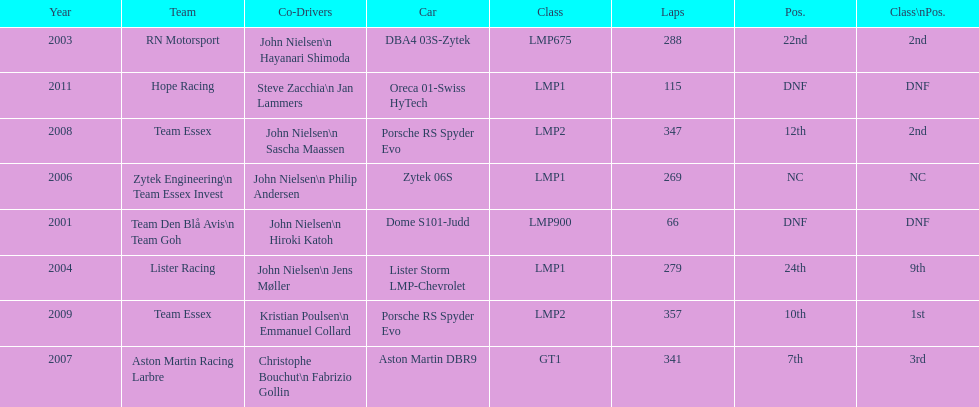How many times was the final position above 20? 2. 